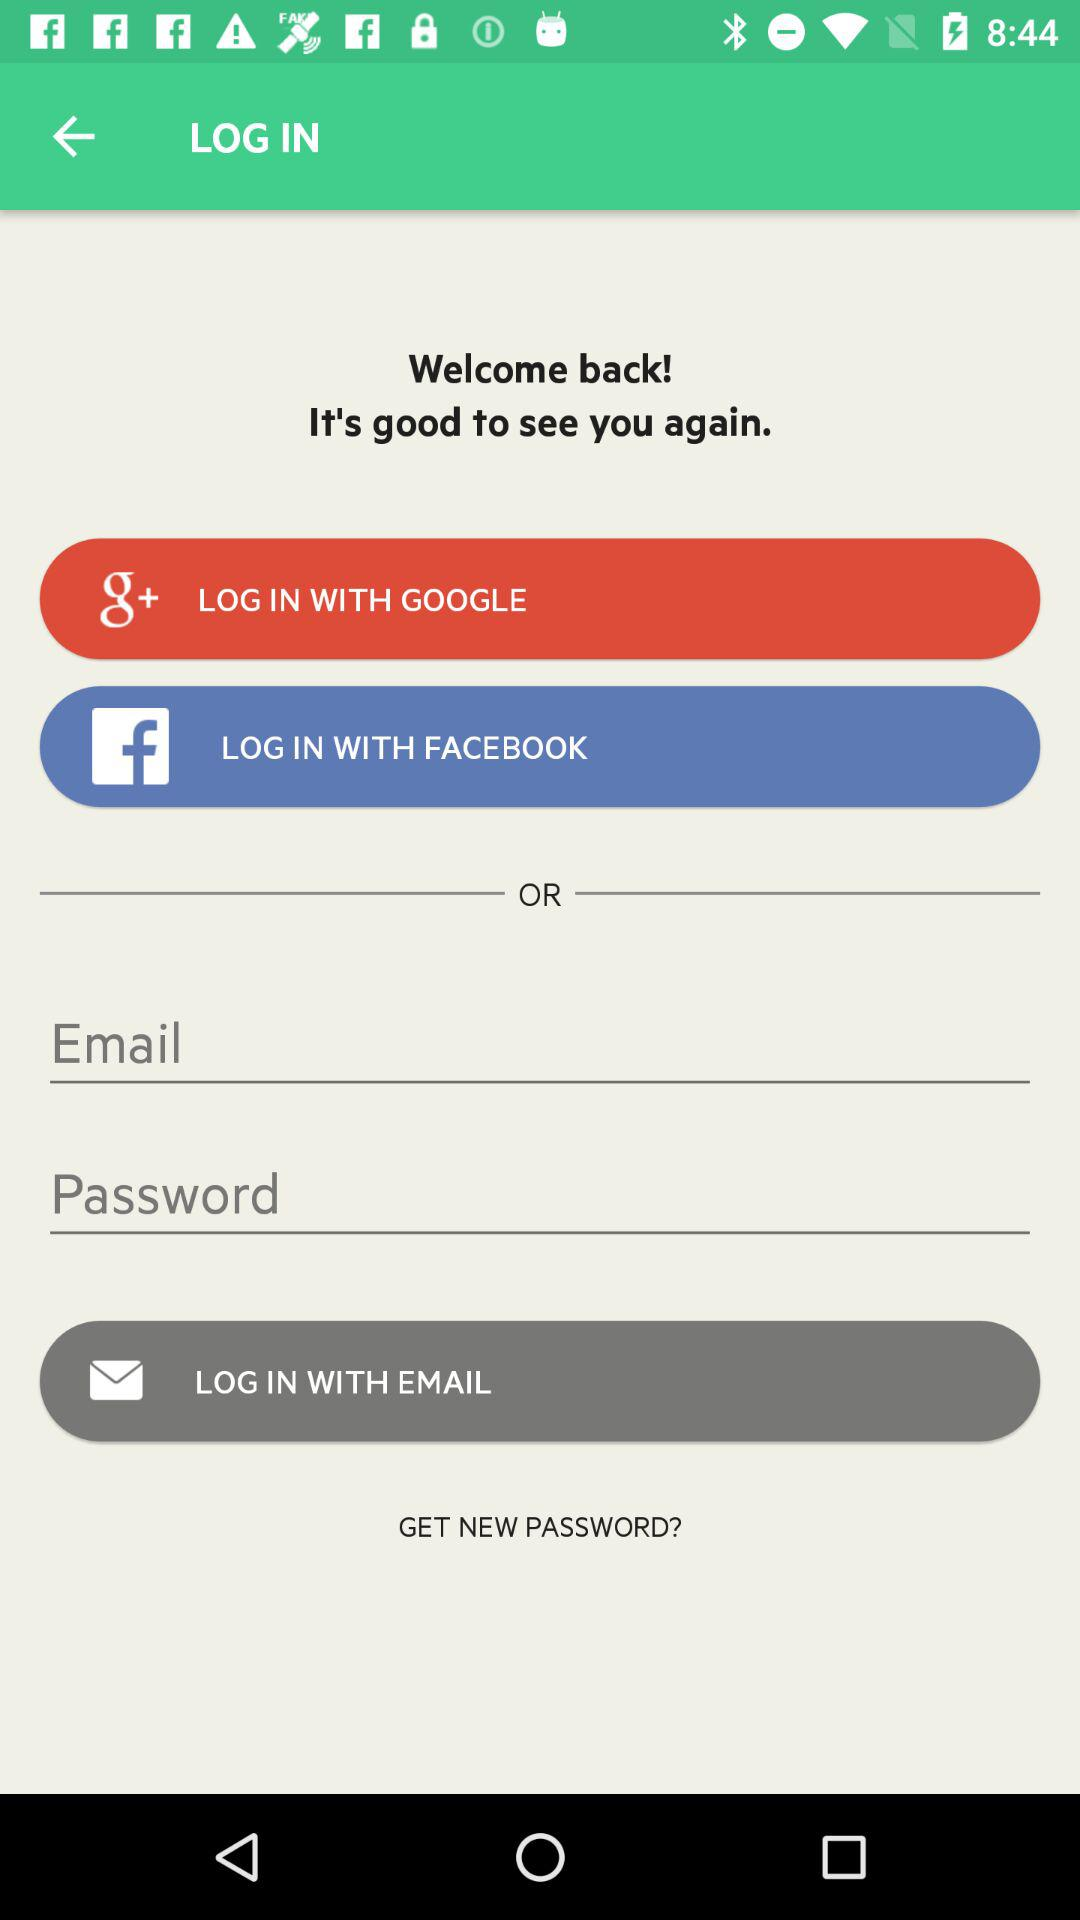Through what applications can we log in? The applications are "GOOGLE" and "FACEBOOK". 